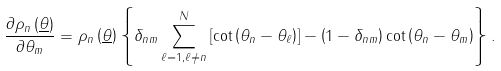Convert formula to latex. <formula><loc_0><loc_0><loc_500><loc_500>\frac { \partial \rho _ { n } \left ( \underline { \theta } \right ) } { \partial \theta _ { m } } = \rho _ { n } \left ( \underline { \theta } \right ) \left \{ \delta _ { n m } \sum _ { \ell = 1 , \ell \neq n } ^ { N } \left [ \cot \left ( \theta _ { n } - \theta _ { \ell } \right ) \right ] - \left ( 1 - \delta _ { n m } \right ) \cot \left ( \theta _ { n } - \theta _ { m } \right ) \right \} .</formula> 